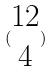Convert formula to latex. <formula><loc_0><loc_0><loc_500><loc_500>( \begin{matrix} 1 2 \\ 4 \end{matrix} )</formula> 